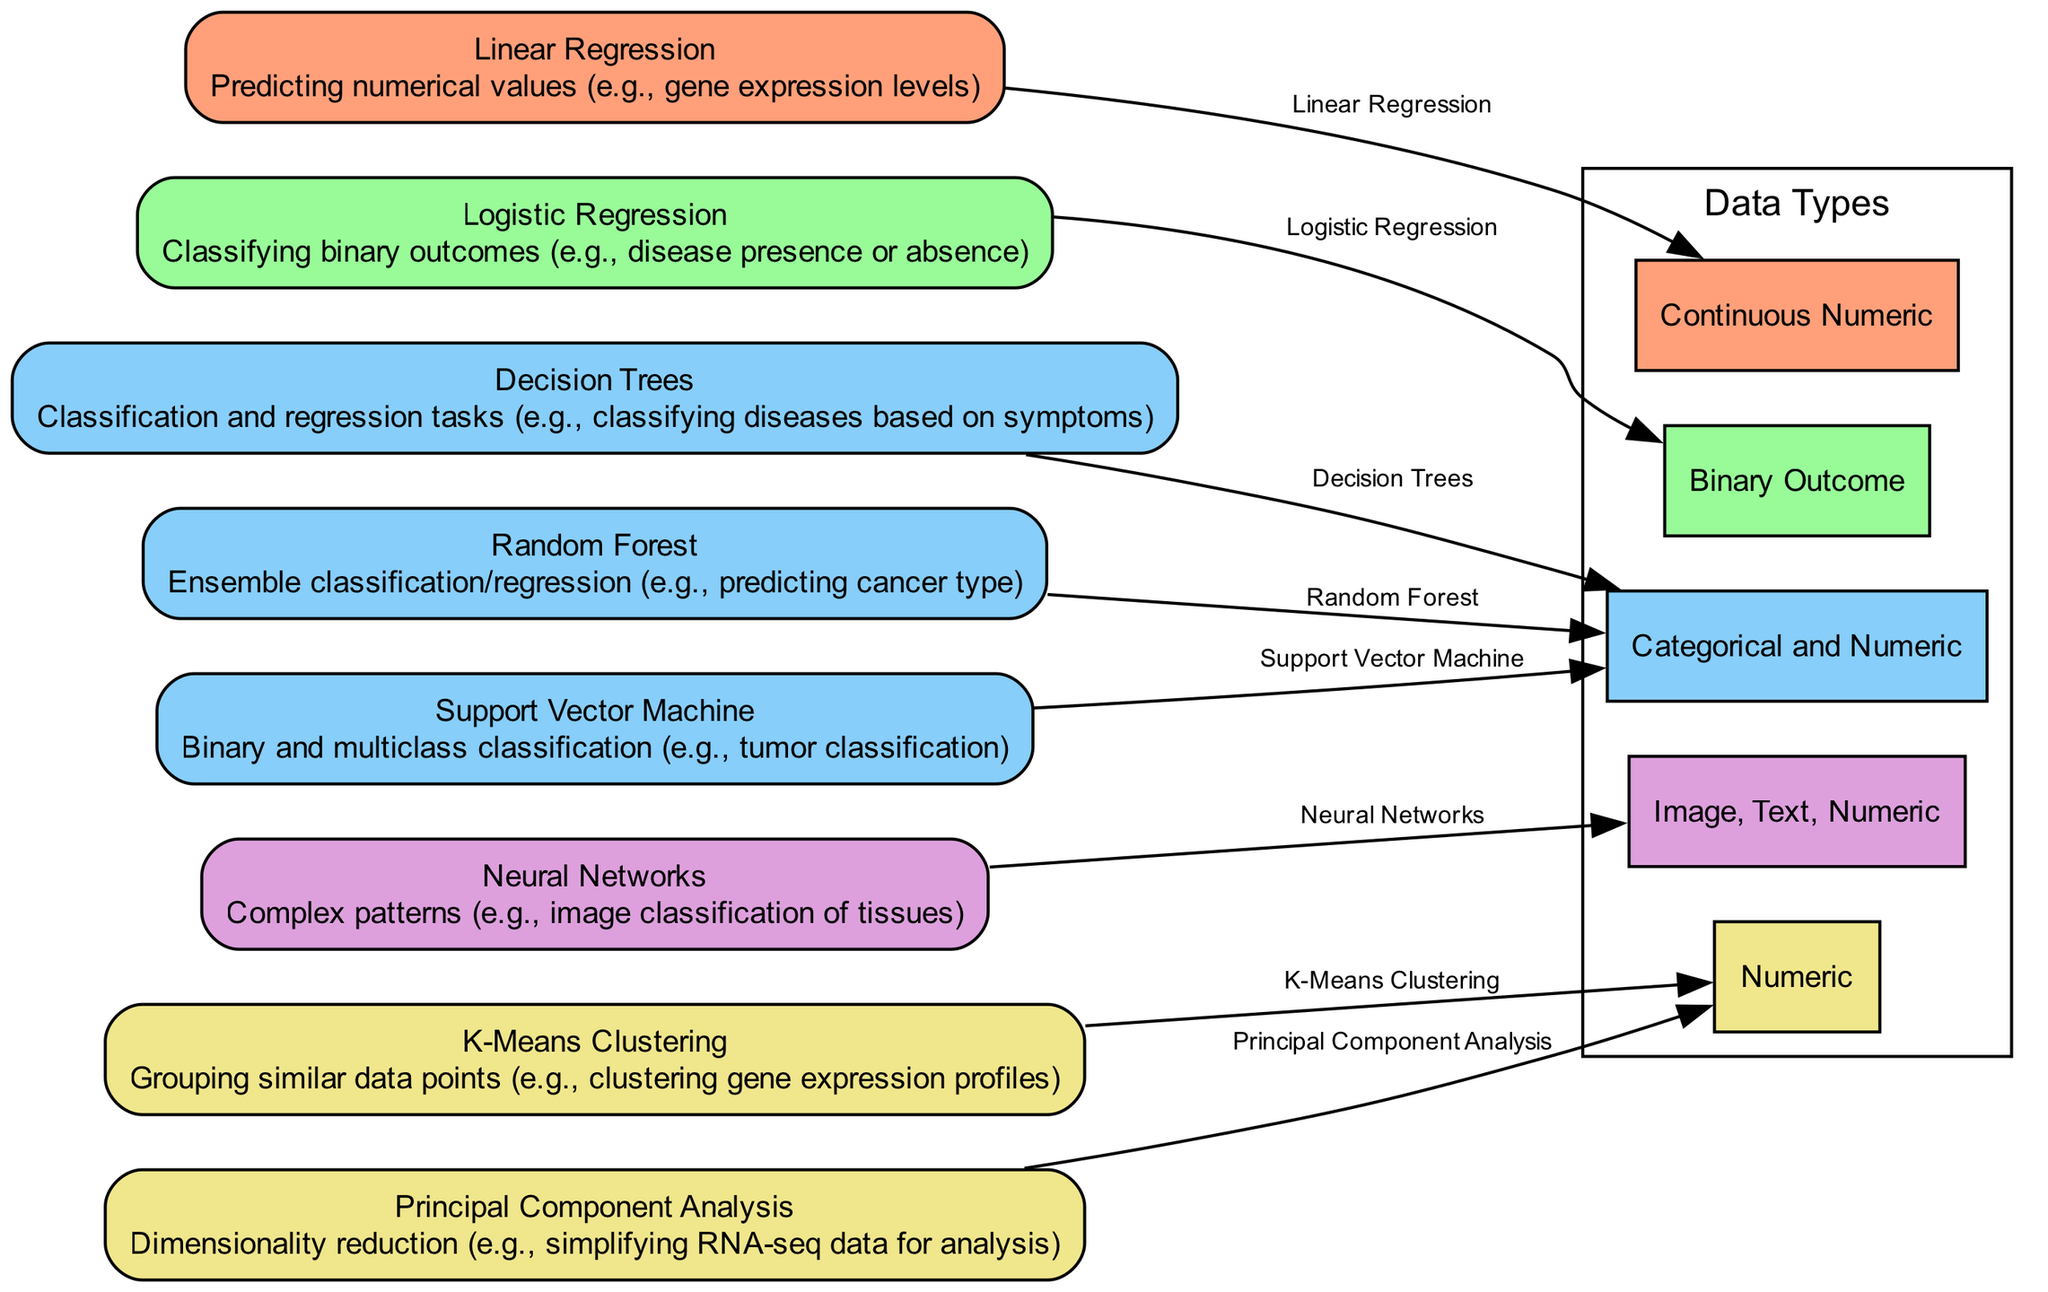What is the outcome of using Neural Networks? The diagram shows that Neural Networks are used for identifying complex patterns, illustrated by the outcome of image classification of tissues.
Answer: Complex patterns How many nodes are present in the diagram? By counting the nodes listed in the diagram, we see there are a total of eight distinct algorithms included.
Answer: 8 Which algorithms are associated with Categorical and Numeric data types? The diagram indicates that Decision Trees, Random Forest, and Support Vector Machine all relate to Categorical and Numeric data types.
Answer: Decision Trees, Random Forest, Support Vector Machine What is the outcome associated with K-Means Clustering? The diagram states that K-Means Clustering is used for grouping similar data points, with a specific example of clustering gene expression profiles.
Answer: Grouping similar data points Which algorithm predicts numerical values? Linear Regression is depicted in the diagram as the algorithm specifically used for predicting numerical values, such as gene expression levels.
Answer: Linear Regression What data type is used by Logistic Regression? The diagram explicitly shows that Logistic Regression uses the Binary Outcome data type.
Answer: Binary Outcome Which machine learning algorithm is used for dimensionality reduction? Principal Component Analysis is the specific algorithm highlighted in the diagram for dimensionality reduction, simplifying RNA-seq data for analysis.
Answer: Principal Component Analysis How does the Support Vector Machine relate to outcomes? The diagram connects Support Vector Machine to various classification tasks, indicating it handles both binary and multiclass classification, including tumor classifications.
Answer: Binary and multiclass classification Which algorithm has the broadest data type usage? The diagram shows Neural Networks as the most versatile, capable of handling Image, Text, and Numeric data types.
Answer: Neural Networks 